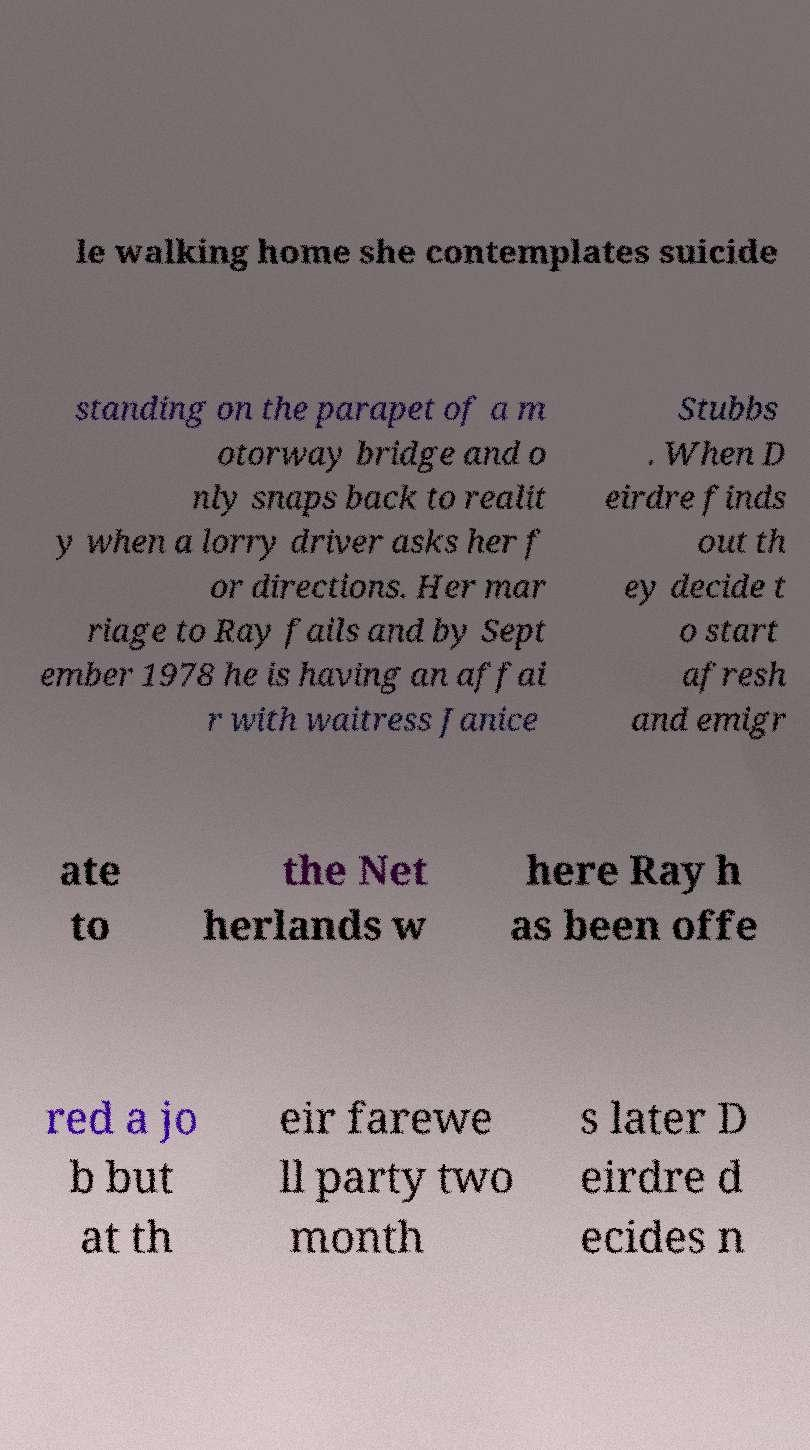What messages or text are displayed in this image? I need them in a readable, typed format. le walking home she contemplates suicide standing on the parapet of a m otorway bridge and o nly snaps back to realit y when a lorry driver asks her f or directions. Her mar riage to Ray fails and by Sept ember 1978 he is having an affai r with waitress Janice Stubbs . When D eirdre finds out th ey decide t o start afresh and emigr ate to the Net herlands w here Ray h as been offe red a jo b but at th eir farewe ll party two month s later D eirdre d ecides n 